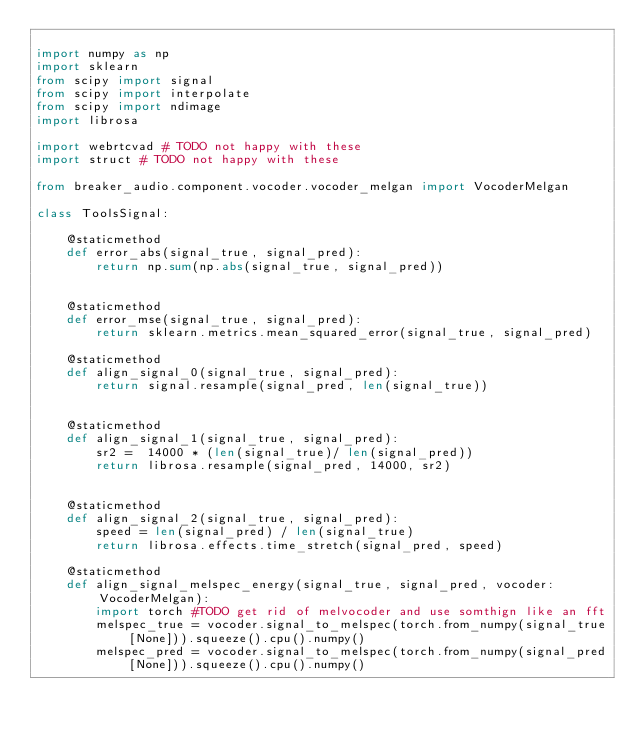<code> <loc_0><loc_0><loc_500><loc_500><_Python_>
import numpy as np
import sklearn
from scipy import signal
from scipy import interpolate
from scipy import ndimage
import librosa

import webrtcvad # TODO not happy with these
import struct # TODO not happy with these

from breaker_audio.component.vocoder.vocoder_melgan import VocoderMelgan

class ToolsSignal:

    @staticmethod
    def error_abs(signal_true, signal_pred):
        return np.sum(np.abs(signal_true, signal_pred))

    
    @staticmethod
    def error_mse(signal_true, signal_pred):
        return sklearn.metrics.mean_squared_error(signal_true, signal_pred)

    @staticmethod
    def align_signal_0(signal_true, signal_pred):
        return signal.resample(signal_pred, len(signal_true))
        

    @staticmethod
    def align_signal_1(signal_true, signal_pred):
        sr2 =  14000 * (len(signal_true)/ len(signal_pred)) 
        return librosa.resample(signal_pred, 14000, sr2)
        

    @staticmethod
    def align_signal_2(signal_true, signal_pred):
        speed = len(signal_pred) / len(signal_true)
        return librosa.effects.time_stretch(signal_pred, speed)

    @staticmethod
    def align_signal_melspec_energy(signal_true, signal_pred, vocoder:VocoderMelgan):
        import torch #TODO get rid of melvocoder and use somthign like an fft
        melspec_true = vocoder.signal_to_melspec(torch.from_numpy(signal_true[None])).squeeze().cpu().numpy()
        melspec_pred = vocoder.signal_to_melspec(torch.from_numpy(signal_pred[None])).squeeze().cpu().numpy()</code> 